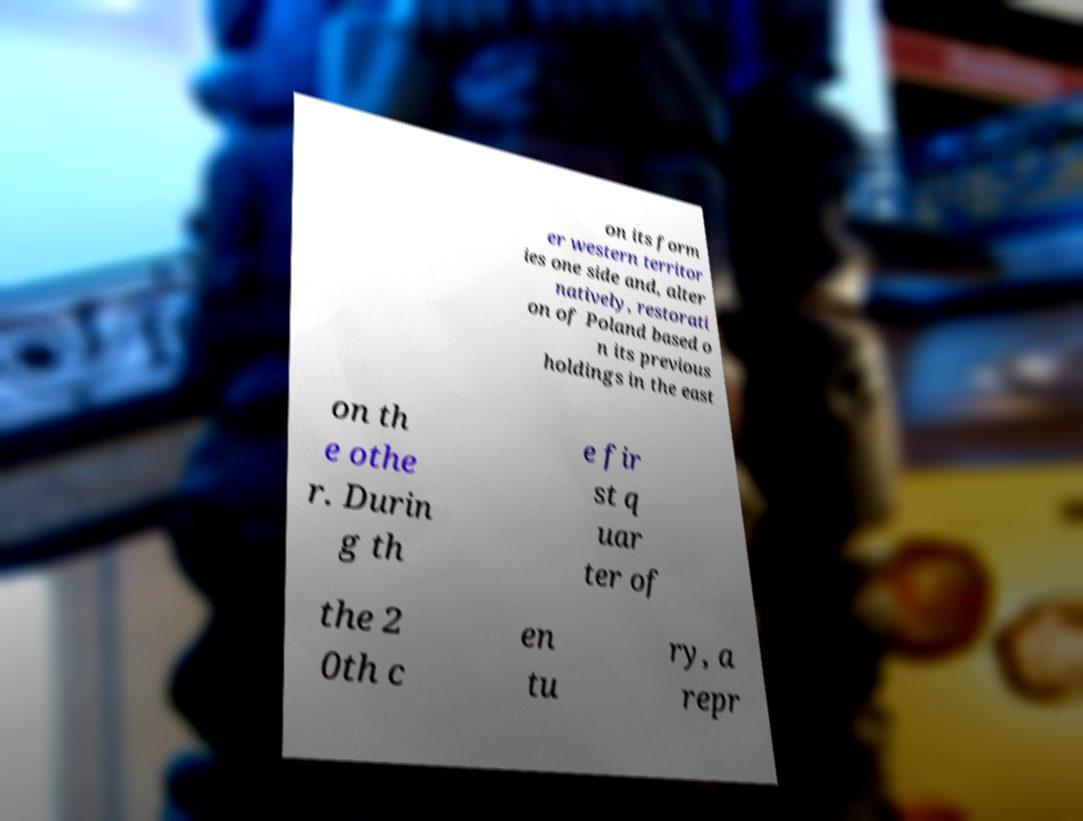Please read and relay the text visible in this image. What does it say? on its form er western territor ies one side and, alter natively, restorati on of Poland based o n its previous holdings in the east on th e othe r. Durin g th e fir st q uar ter of the 2 0th c en tu ry, a repr 